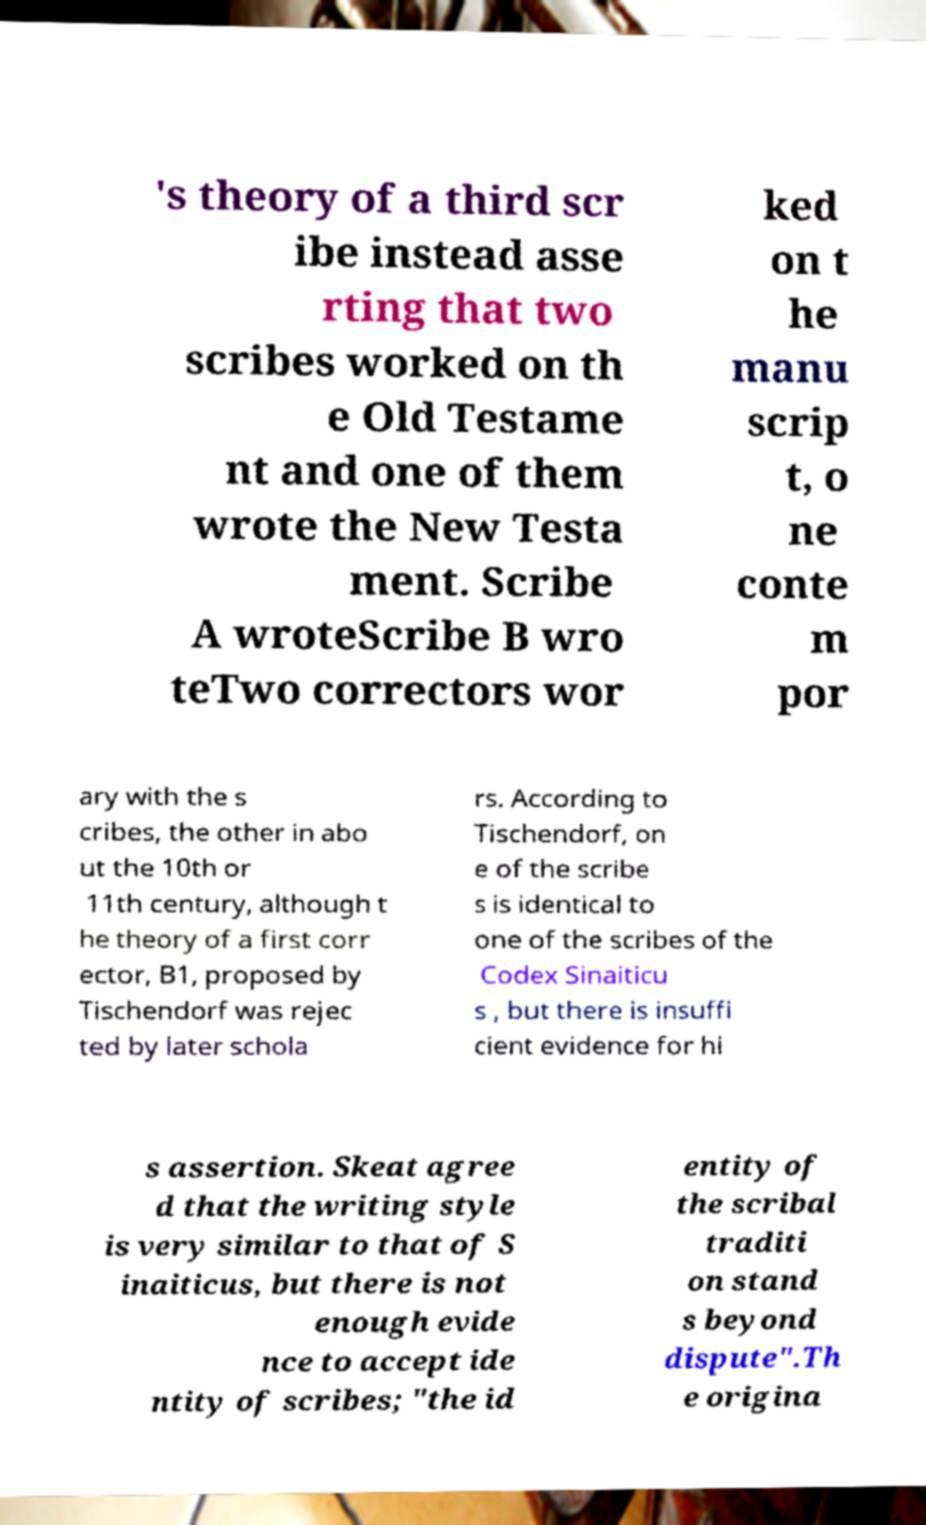Please read and relay the text visible in this image. What does it say? 's theory of a third scr ibe instead asse rting that two scribes worked on th e Old Testame nt and one of them wrote the New Testa ment. Scribe A wroteScribe B wro teTwo correctors wor ked on t he manu scrip t, o ne conte m por ary with the s cribes, the other in abo ut the 10th or 11th century, although t he theory of a first corr ector, B1, proposed by Tischendorf was rejec ted by later schola rs. According to Tischendorf, on e of the scribe s is identical to one of the scribes of the Codex Sinaiticu s , but there is insuffi cient evidence for hi s assertion. Skeat agree d that the writing style is very similar to that of S inaiticus, but there is not enough evide nce to accept ide ntity of scribes; "the id entity of the scribal traditi on stand s beyond dispute".Th e origina 